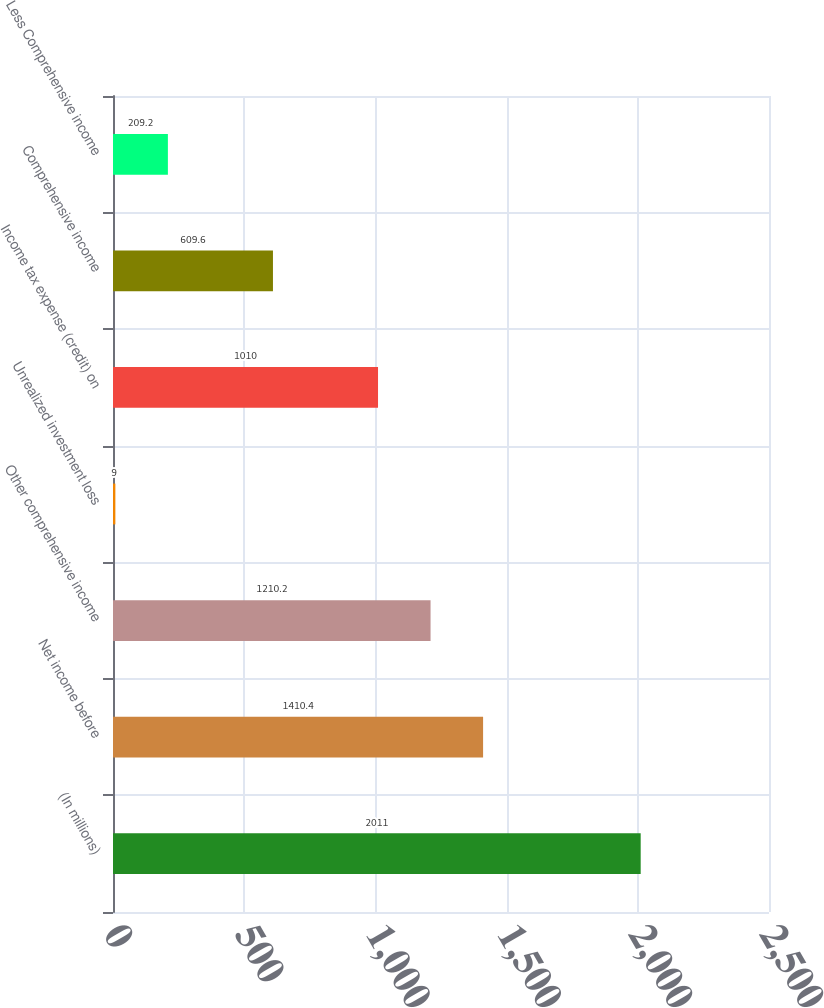<chart> <loc_0><loc_0><loc_500><loc_500><bar_chart><fcel>(In millions)<fcel>Net income before<fcel>Other comprehensive income<fcel>Unrealized investment loss<fcel>Income tax expense (credit) on<fcel>Comprehensive income<fcel>Less Comprehensive income<nl><fcel>2011<fcel>1410.4<fcel>1210.2<fcel>9<fcel>1010<fcel>609.6<fcel>209.2<nl></chart> 